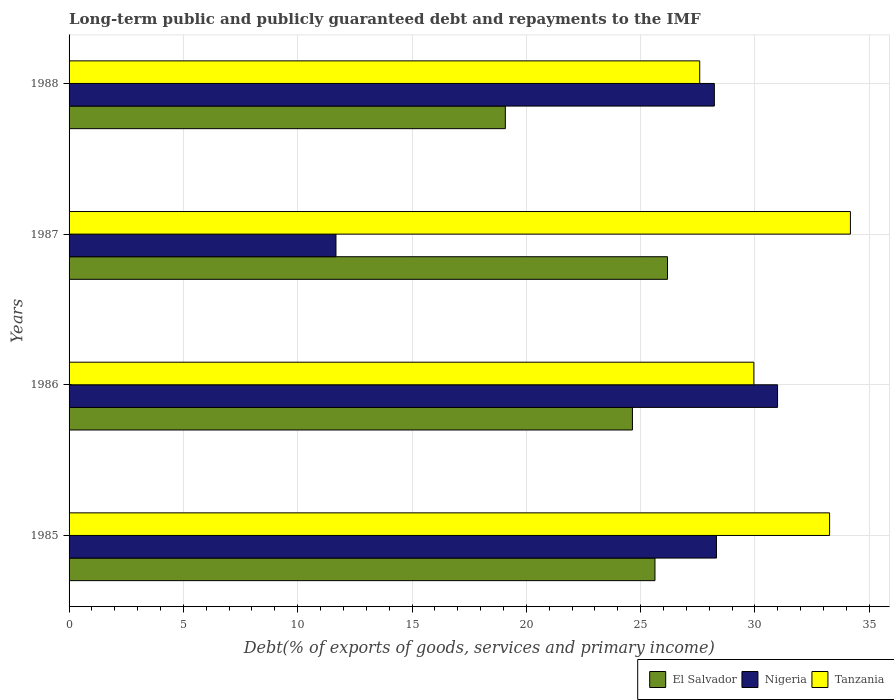How many different coloured bars are there?
Your answer should be compact. 3. How many groups of bars are there?
Provide a short and direct response. 4. Are the number of bars per tick equal to the number of legend labels?
Give a very brief answer. Yes. How many bars are there on the 2nd tick from the top?
Your answer should be very brief. 3. How many bars are there on the 1st tick from the bottom?
Ensure brevity in your answer.  3. What is the label of the 4th group of bars from the top?
Your answer should be very brief. 1985. In how many cases, is the number of bars for a given year not equal to the number of legend labels?
Provide a short and direct response. 0. What is the debt and repayments in El Salvador in 1987?
Offer a terse response. 26.18. Across all years, what is the maximum debt and repayments in Tanzania?
Ensure brevity in your answer.  34.18. Across all years, what is the minimum debt and repayments in El Salvador?
Provide a succinct answer. 19.08. In which year was the debt and repayments in Nigeria minimum?
Give a very brief answer. 1987. What is the total debt and repayments in Nigeria in the graph?
Your answer should be compact. 99.21. What is the difference between the debt and repayments in Tanzania in 1986 and that in 1988?
Make the answer very short. 2.37. What is the difference between the debt and repayments in Tanzania in 1985 and the debt and repayments in El Salvador in 1986?
Offer a terse response. 8.62. What is the average debt and repayments in Nigeria per year?
Make the answer very short. 24.8. In the year 1985, what is the difference between the debt and repayments in Tanzania and debt and repayments in El Salvador?
Give a very brief answer. 7.64. In how many years, is the debt and repayments in Nigeria greater than 34 %?
Provide a succinct answer. 0. What is the ratio of the debt and repayments in Nigeria in 1985 to that in 1988?
Keep it short and to the point. 1. Is the debt and repayments in Nigeria in 1985 less than that in 1986?
Provide a short and direct response. Yes. What is the difference between the highest and the second highest debt and repayments in Tanzania?
Your answer should be very brief. 0.91. What is the difference between the highest and the lowest debt and repayments in Nigeria?
Your response must be concise. 19.32. Is the sum of the debt and repayments in El Salvador in 1986 and 1987 greater than the maximum debt and repayments in Tanzania across all years?
Provide a succinct answer. Yes. What does the 2nd bar from the top in 1985 represents?
Give a very brief answer. Nigeria. What does the 2nd bar from the bottom in 1987 represents?
Keep it short and to the point. Nigeria. Are all the bars in the graph horizontal?
Your answer should be very brief. Yes. Does the graph contain any zero values?
Offer a terse response. No. Where does the legend appear in the graph?
Give a very brief answer. Bottom right. How many legend labels are there?
Make the answer very short. 3. How are the legend labels stacked?
Ensure brevity in your answer.  Horizontal. What is the title of the graph?
Provide a succinct answer. Long-term public and publicly guaranteed debt and repayments to the IMF. What is the label or title of the X-axis?
Your answer should be very brief. Debt(% of exports of goods, services and primary income). What is the Debt(% of exports of goods, services and primary income) of El Salvador in 1985?
Give a very brief answer. 25.63. What is the Debt(% of exports of goods, services and primary income) of Nigeria in 1985?
Make the answer very short. 28.32. What is the Debt(% of exports of goods, services and primary income) of Tanzania in 1985?
Make the answer very short. 33.27. What is the Debt(% of exports of goods, services and primary income) of El Salvador in 1986?
Offer a terse response. 24.64. What is the Debt(% of exports of goods, services and primary income) in Nigeria in 1986?
Provide a succinct answer. 30.99. What is the Debt(% of exports of goods, services and primary income) of Tanzania in 1986?
Ensure brevity in your answer.  29.95. What is the Debt(% of exports of goods, services and primary income) in El Salvador in 1987?
Your response must be concise. 26.18. What is the Debt(% of exports of goods, services and primary income) of Nigeria in 1987?
Your response must be concise. 11.67. What is the Debt(% of exports of goods, services and primary income) of Tanzania in 1987?
Your response must be concise. 34.18. What is the Debt(% of exports of goods, services and primary income) in El Salvador in 1988?
Your answer should be compact. 19.08. What is the Debt(% of exports of goods, services and primary income) of Nigeria in 1988?
Provide a succinct answer. 28.23. What is the Debt(% of exports of goods, services and primary income) in Tanzania in 1988?
Keep it short and to the point. 27.59. Across all years, what is the maximum Debt(% of exports of goods, services and primary income) in El Salvador?
Offer a very short reply. 26.18. Across all years, what is the maximum Debt(% of exports of goods, services and primary income) in Nigeria?
Provide a short and direct response. 30.99. Across all years, what is the maximum Debt(% of exports of goods, services and primary income) of Tanzania?
Keep it short and to the point. 34.18. Across all years, what is the minimum Debt(% of exports of goods, services and primary income) in El Salvador?
Your answer should be compact. 19.08. Across all years, what is the minimum Debt(% of exports of goods, services and primary income) in Nigeria?
Provide a succinct answer. 11.67. Across all years, what is the minimum Debt(% of exports of goods, services and primary income) of Tanzania?
Offer a terse response. 27.59. What is the total Debt(% of exports of goods, services and primary income) of El Salvador in the graph?
Give a very brief answer. 95.53. What is the total Debt(% of exports of goods, services and primary income) in Nigeria in the graph?
Make the answer very short. 99.21. What is the total Debt(% of exports of goods, services and primary income) of Tanzania in the graph?
Offer a terse response. 124.98. What is the difference between the Debt(% of exports of goods, services and primary income) in El Salvador in 1985 and that in 1986?
Offer a terse response. 0.99. What is the difference between the Debt(% of exports of goods, services and primary income) of Nigeria in 1985 and that in 1986?
Make the answer very short. -2.67. What is the difference between the Debt(% of exports of goods, services and primary income) in Tanzania in 1985 and that in 1986?
Provide a short and direct response. 3.31. What is the difference between the Debt(% of exports of goods, services and primary income) in El Salvador in 1985 and that in 1987?
Offer a terse response. -0.55. What is the difference between the Debt(% of exports of goods, services and primary income) of Nigeria in 1985 and that in 1987?
Provide a succinct answer. 16.64. What is the difference between the Debt(% of exports of goods, services and primary income) in Tanzania in 1985 and that in 1987?
Offer a very short reply. -0.91. What is the difference between the Debt(% of exports of goods, services and primary income) in El Salvador in 1985 and that in 1988?
Your answer should be very brief. 6.54. What is the difference between the Debt(% of exports of goods, services and primary income) in Nigeria in 1985 and that in 1988?
Offer a terse response. 0.09. What is the difference between the Debt(% of exports of goods, services and primary income) of Tanzania in 1985 and that in 1988?
Ensure brevity in your answer.  5.68. What is the difference between the Debt(% of exports of goods, services and primary income) of El Salvador in 1986 and that in 1987?
Ensure brevity in your answer.  -1.53. What is the difference between the Debt(% of exports of goods, services and primary income) of Nigeria in 1986 and that in 1987?
Offer a terse response. 19.32. What is the difference between the Debt(% of exports of goods, services and primary income) in Tanzania in 1986 and that in 1987?
Keep it short and to the point. -4.22. What is the difference between the Debt(% of exports of goods, services and primary income) of El Salvador in 1986 and that in 1988?
Your answer should be very brief. 5.56. What is the difference between the Debt(% of exports of goods, services and primary income) in Nigeria in 1986 and that in 1988?
Make the answer very short. 2.76. What is the difference between the Debt(% of exports of goods, services and primary income) of Tanzania in 1986 and that in 1988?
Make the answer very short. 2.37. What is the difference between the Debt(% of exports of goods, services and primary income) of El Salvador in 1987 and that in 1988?
Keep it short and to the point. 7.09. What is the difference between the Debt(% of exports of goods, services and primary income) in Nigeria in 1987 and that in 1988?
Your response must be concise. -16.55. What is the difference between the Debt(% of exports of goods, services and primary income) of Tanzania in 1987 and that in 1988?
Your answer should be very brief. 6.59. What is the difference between the Debt(% of exports of goods, services and primary income) in El Salvador in 1985 and the Debt(% of exports of goods, services and primary income) in Nigeria in 1986?
Provide a succinct answer. -5.36. What is the difference between the Debt(% of exports of goods, services and primary income) of El Salvador in 1985 and the Debt(% of exports of goods, services and primary income) of Tanzania in 1986?
Keep it short and to the point. -4.33. What is the difference between the Debt(% of exports of goods, services and primary income) of Nigeria in 1985 and the Debt(% of exports of goods, services and primary income) of Tanzania in 1986?
Keep it short and to the point. -1.64. What is the difference between the Debt(% of exports of goods, services and primary income) in El Salvador in 1985 and the Debt(% of exports of goods, services and primary income) in Nigeria in 1987?
Give a very brief answer. 13.95. What is the difference between the Debt(% of exports of goods, services and primary income) of El Salvador in 1985 and the Debt(% of exports of goods, services and primary income) of Tanzania in 1987?
Offer a terse response. -8.55. What is the difference between the Debt(% of exports of goods, services and primary income) of Nigeria in 1985 and the Debt(% of exports of goods, services and primary income) of Tanzania in 1987?
Ensure brevity in your answer.  -5.86. What is the difference between the Debt(% of exports of goods, services and primary income) in El Salvador in 1985 and the Debt(% of exports of goods, services and primary income) in Nigeria in 1988?
Keep it short and to the point. -2.6. What is the difference between the Debt(% of exports of goods, services and primary income) in El Salvador in 1985 and the Debt(% of exports of goods, services and primary income) in Tanzania in 1988?
Offer a terse response. -1.96. What is the difference between the Debt(% of exports of goods, services and primary income) of Nigeria in 1985 and the Debt(% of exports of goods, services and primary income) of Tanzania in 1988?
Offer a very short reply. 0.73. What is the difference between the Debt(% of exports of goods, services and primary income) of El Salvador in 1986 and the Debt(% of exports of goods, services and primary income) of Nigeria in 1987?
Provide a short and direct response. 12.97. What is the difference between the Debt(% of exports of goods, services and primary income) of El Salvador in 1986 and the Debt(% of exports of goods, services and primary income) of Tanzania in 1987?
Offer a very short reply. -9.54. What is the difference between the Debt(% of exports of goods, services and primary income) of Nigeria in 1986 and the Debt(% of exports of goods, services and primary income) of Tanzania in 1987?
Offer a very short reply. -3.19. What is the difference between the Debt(% of exports of goods, services and primary income) in El Salvador in 1986 and the Debt(% of exports of goods, services and primary income) in Nigeria in 1988?
Your answer should be very brief. -3.58. What is the difference between the Debt(% of exports of goods, services and primary income) in El Salvador in 1986 and the Debt(% of exports of goods, services and primary income) in Tanzania in 1988?
Keep it short and to the point. -2.94. What is the difference between the Debt(% of exports of goods, services and primary income) in Nigeria in 1986 and the Debt(% of exports of goods, services and primary income) in Tanzania in 1988?
Your answer should be compact. 3.41. What is the difference between the Debt(% of exports of goods, services and primary income) of El Salvador in 1987 and the Debt(% of exports of goods, services and primary income) of Nigeria in 1988?
Make the answer very short. -2.05. What is the difference between the Debt(% of exports of goods, services and primary income) of El Salvador in 1987 and the Debt(% of exports of goods, services and primary income) of Tanzania in 1988?
Make the answer very short. -1.41. What is the difference between the Debt(% of exports of goods, services and primary income) in Nigeria in 1987 and the Debt(% of exports of goods, services and primary income) in Tanzania in 1988?
Offer a very short reply. -15.91. What is the average Debt(% of exports of goods, services and primary income) in El Salvador per year?
Offer a terse response. 23.88. What is the average Debt(% of exports of goods, services and primary income) of Nigeria per year?
Your answer should be compact. 24.8. What is the average Debt(% of exports of goods, services and primary income) of Tanzania per year?
Give a very brief answer. 31.25. In the year 1985, what is the difference between the Debt(% of exports of goods, services and primary income) of El Salvador and Debt(% of exports of goods, services and primary income) of Nigeria?
Provide a succinct answer. -2.69. In the year 1985, what is the difference between the Debt(% of exports of goods, services and primary income) of El Salvador and Debt(% of exports of goods, services and primary income) of Tanzania?
Keep it short and to the point. -7.64. In the year 1985, what is the difference between the Debt(% of exports of goods, services and primary income) of Nigeria and Debt(% of exports of goods, services and primary income) of Tanzania?
Your answer should be compact. -4.95. In the year 1986, what is the difference between the Debt(% of exports of goods, services and primary income) of El Salvador and Debt(% of exports of goods, services and primary income) of Nigeria?
Your answer should be compact. -6.35. In the year 1986, what is the difference between the Debt(% of exports of goods, services and primary income) in El Salvador and Debt(% of exports of goods, services and primary income) in Tanzania?
Your answer should be very brief. -5.31. In the year 1986, what is the difference between the Debt(% of exports of goods, services and primary income) in Nigeria and Debt(% of exports of goods, services and primary income) in Tanzania?
Offer a terse response. 1.04. In the year 1987, what is the difference between the Debt(% of exports of goods, services and primary income) in El Salvador and Debt(% of exports of goods, services and primary income) in Nigeria?
Offer a terse response. 14.5. In the year 1987, what is the difference between the Debt(% of exports of goods, services and primary income) of El Salvador and Debt(% of exports of goods, services and primary income) of Tanzania?
Provide a succinct answer. -8. In the year 1987, what is the difference between the Debt(% of exports of goods, services and primary income) of Nigeria and Debt(% of exports of goods, services and primary income) of Tanzania?
Your answer should be very brief. -22.5. In the year 1988, what is the difference between the Debt(% of exports of goods, services and primary income) of El Salvador and Debt(% of exports of goods, services and primary income) of Nigeria?
Keep it short and to the point. -9.14. In the year 1988, what is the difference between the Debt(% of exports of goods, services and primary income) of El Salvador and Debt(% of exports of goods, services and primary income) of Tanzania?
Provide a succinct answer. -8.5. In the year 1988, what is the difference between the Debt(% of exports of goods, services and primary income) in Nigeria and Debt(% of exports of goods, services and primary income) in Tanzania?
Your answer should be compact. 0.64. What is the ratio of the Debt(% of exports of goods, services and primary income) of Nigeria in 1985 to that in 1986?
Offer a terse response. 0.91. What is the ratio of the Debt(% of exports of goods, services and primary income) of Tanzania in 1985 to that in 1986?
Ensure brevity in your answer.  1.11. What is the ratio of the Debt(% of exports of goods, services and primary income) in El Salvador in 1985 to that in 1987?
Provide a short and direct response. 0.98. What is the ratio of the Debt(% of exports of goods, services and primary income) of Nigeria in 1985 to that in 1987?
Offer a very short reply. 2.43. What is the ratio of the Debt(% of exports of goods, services and primary income) of Tanzania in 1985 to that in 1987?
Offer a very short reply. 0.97. What is the ratio of the Debt(% of exports of goods, services and primary income) in El Salvador in 1985 to that in 1988?
Ensure brevity in your answer.  1.34. What is the ratio of the Debt(% of exports of goods, services and primary income) in Nigeria in 1985 to that in 1988?
Your response must be concise. 1. What is the ratio of the Debt(% of exports of goods, services and primary income) of Tanzania in 1985 to that in 1988?
Give a very brief answer. 1.21. What is the ratio of the Debt(% of exports of goods, services and primary income) in El Salvador in 1986 to that in 1987?
Your response must be concise. 0.94. What is the ratio of the Debt(% of exports of goods, services and primary income) of Nigeria in 1986 to that in 1987?
Offer a very short reply. 2.65. What is the ratio of the Debt(% of exports of goods, services and primary income) of Tanzania in 1986 to that in 1987?
Make the answer very short. 0.88. What is the ratio of the Debt(% of exports of goods, services and primary income) of El Salvador in 1986 to that in 1988?
Ensure brevity in your answer.  1.29. What is the ratio of the Debt(% of exports of goods, services and primary income) in Nigeria in 1986 to that in 1988?
Keep it short and to the point. 1.1. What is the ratio of the Debt(% of exports of goods, services and primary income) in Tanzania in 1986 to that in 1988?
Provide a short and direct response. 1.09. What is the ratio of the Debt(% of exports of goods, services and primary income) in El Salvador in 1987 to that in 1988?
Offer a terse response. 1.37. What is the ratio of the Debt(% of exports of goods, services and primary income) in Nigeria in 1987 to that in 1988?
Provide a short and direct response. 0.41. What is the ratio of the Debt(% of exports of goods, services and primary income) in Tanzania in 1987 to that in 1988?
Offer a very short reply. 1.24. What is the difference between the highest and the second highest Debt(% of exports of goods, services and primary income) in El Salvador?
Make the answer very short. 0.55. What is the difference between the highest and the second highest Debt(% of exports of goods, services and primary income) in Nigeria?
Your response must be concise. 2.67. What is the difference between the highest and the second highest Debt(% of exports of goods, services and primary income) in Tanzania?
Give a very brief answer. 0.91. What is the difference between the highest and the lowest Debt(% of exports of goods, services and primary income) of El Salvador?
Your response must be concise. 7.09. What is the difference between the highest and the lowest Debt(% of exports of goods, services and primary income) of Nigeria?
Your response must be concise. 19.32. What is the difference between the highest and the lowest Debt(% of exports of goods, services and primary income) of Tanzania?
Offer a terse response. 6.59. 